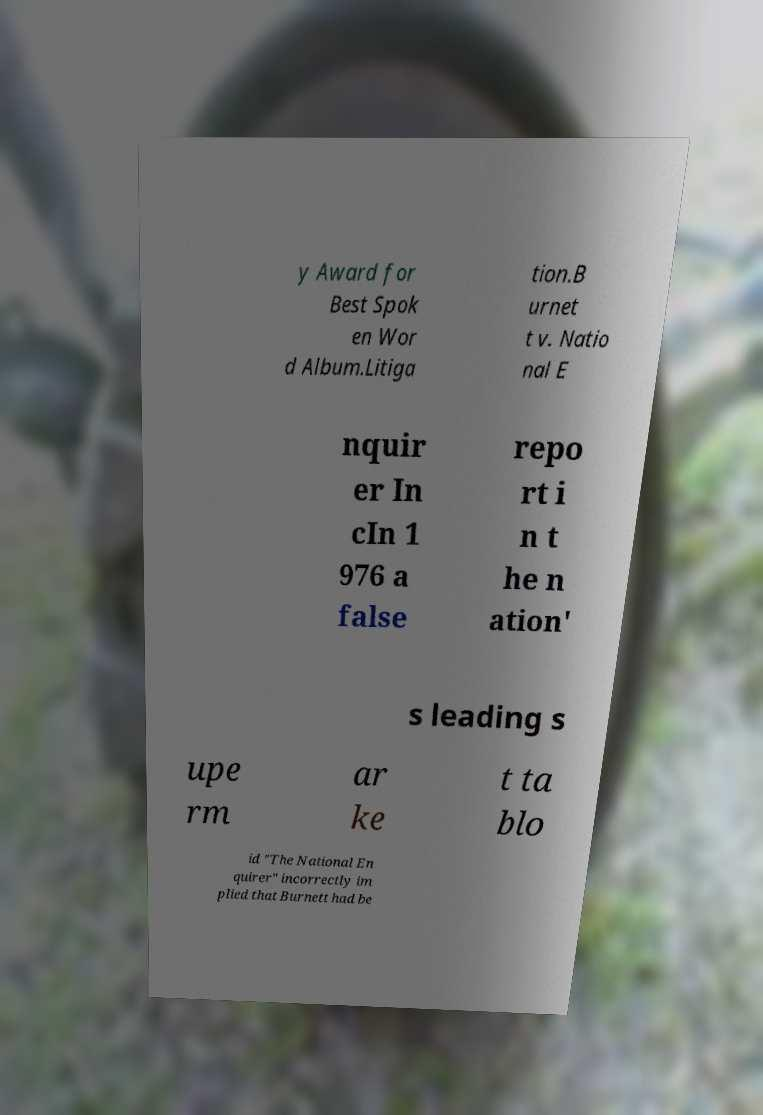Please read and relay the text visible in this image. What does it say? y Award for Best Spok en Wor d Album.Litiga tion.B urnet t v. Natio nal E nquir er In cIn 1 976 a false repo rt i n t he n ation' s leading s upe rm ar ke t ta blo id "The National En quirer" incorrectly im plied that Burnett had be 